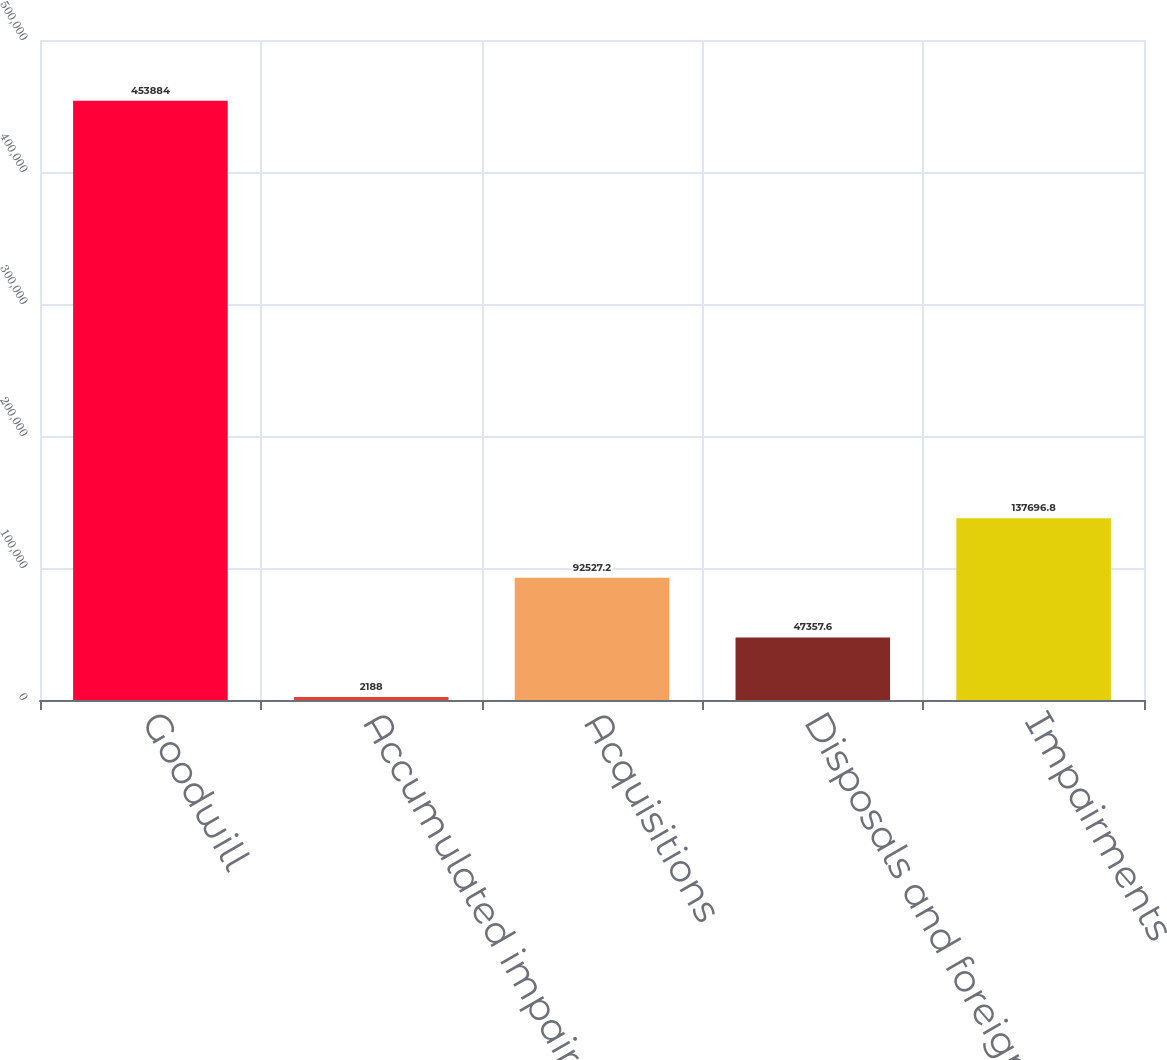<chart> <loc_0><loc_0><loc_500><loc_500><bar_chart><fcel>Goodwill<fcel>Accumulated impairment losses<fcel>Acquisitions<fcel>Disposals and foreign currency<fcel>Impairments<nl><fcel>453884<fcel>2188<fcel>92527.2<fcel>47357.6<fcel>137697<nl></chart> 